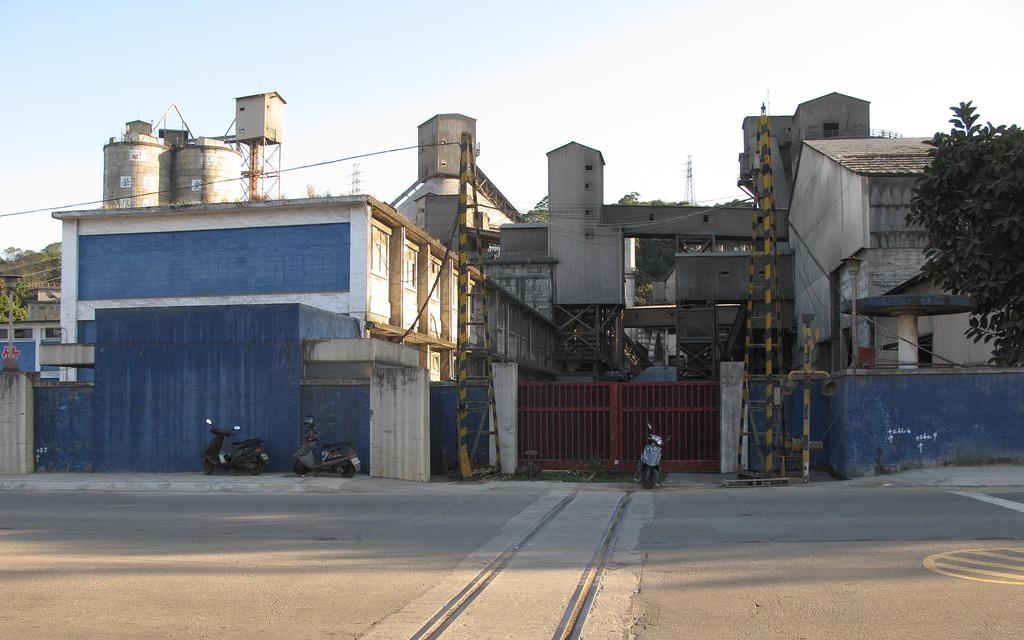What type of structures can be seen in the front of the image? There are buildings, a gate, and walls in the front of the image. What type of transportation is visible in the front of the image? There are vehicles in the front of the image. What type of architectural feature can be seen in the front of the image? There are towers in the front of the image. What type of natural element is present in the front of the image? There are trees in the front of the image. What type of surface can be seen in the front of the image? There is a road in the front of the image. What type of objects can be seen in the front of the image? There are objects in the front of the image. What can be seen in the background of the image? There is sky visible in the background of the image. What type of force is being exerted by the mind in the image? There is no indication of any force being exerted by the mind in the image, as it primarily features buildings, vehicles, and other physical objects. How does the transport system in the image affect the mind? The image does not show any transport system affecting the mind; it only shows vehicles and a road. 